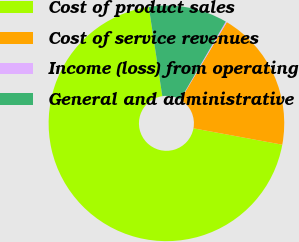<chart> <loc_0><loc_0><loc_500><loc_500><pie_chart><fcel>Cost of product sales<fcel>Cost of service revenues<fcel>Income (loss) from operating<fcel>General and administrative<nl><fcel>69.71%<fcel>19.34%<fcel>0.16%<fcel>10.8%<nl></chart> 